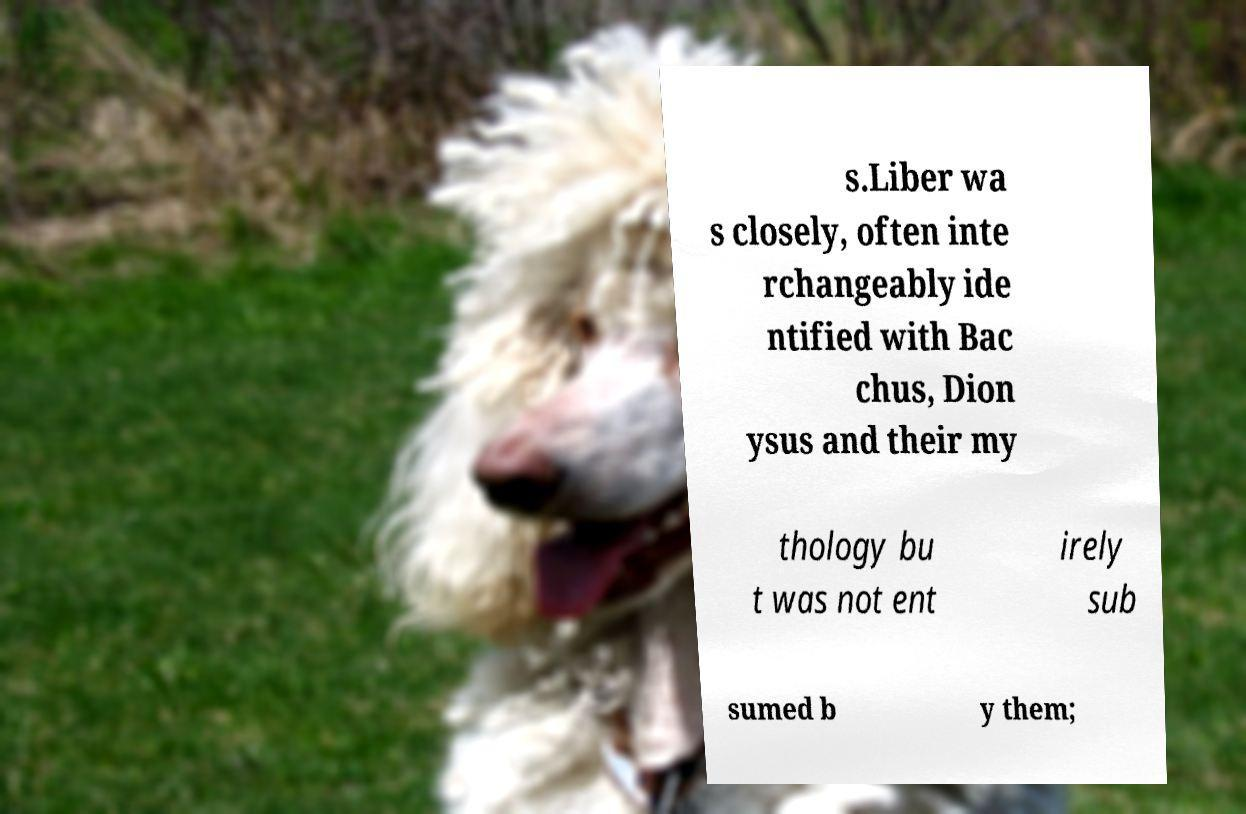Can you read and provide the text displayed in the image?This photo seems to have some interesting text. Can you extract and type it out for me? s.Liber wa s closely, often inte rchangeably ide ntified with Bac chus, Dion ysus and their my thology bu t was not ent irely sub sumed b y them; 